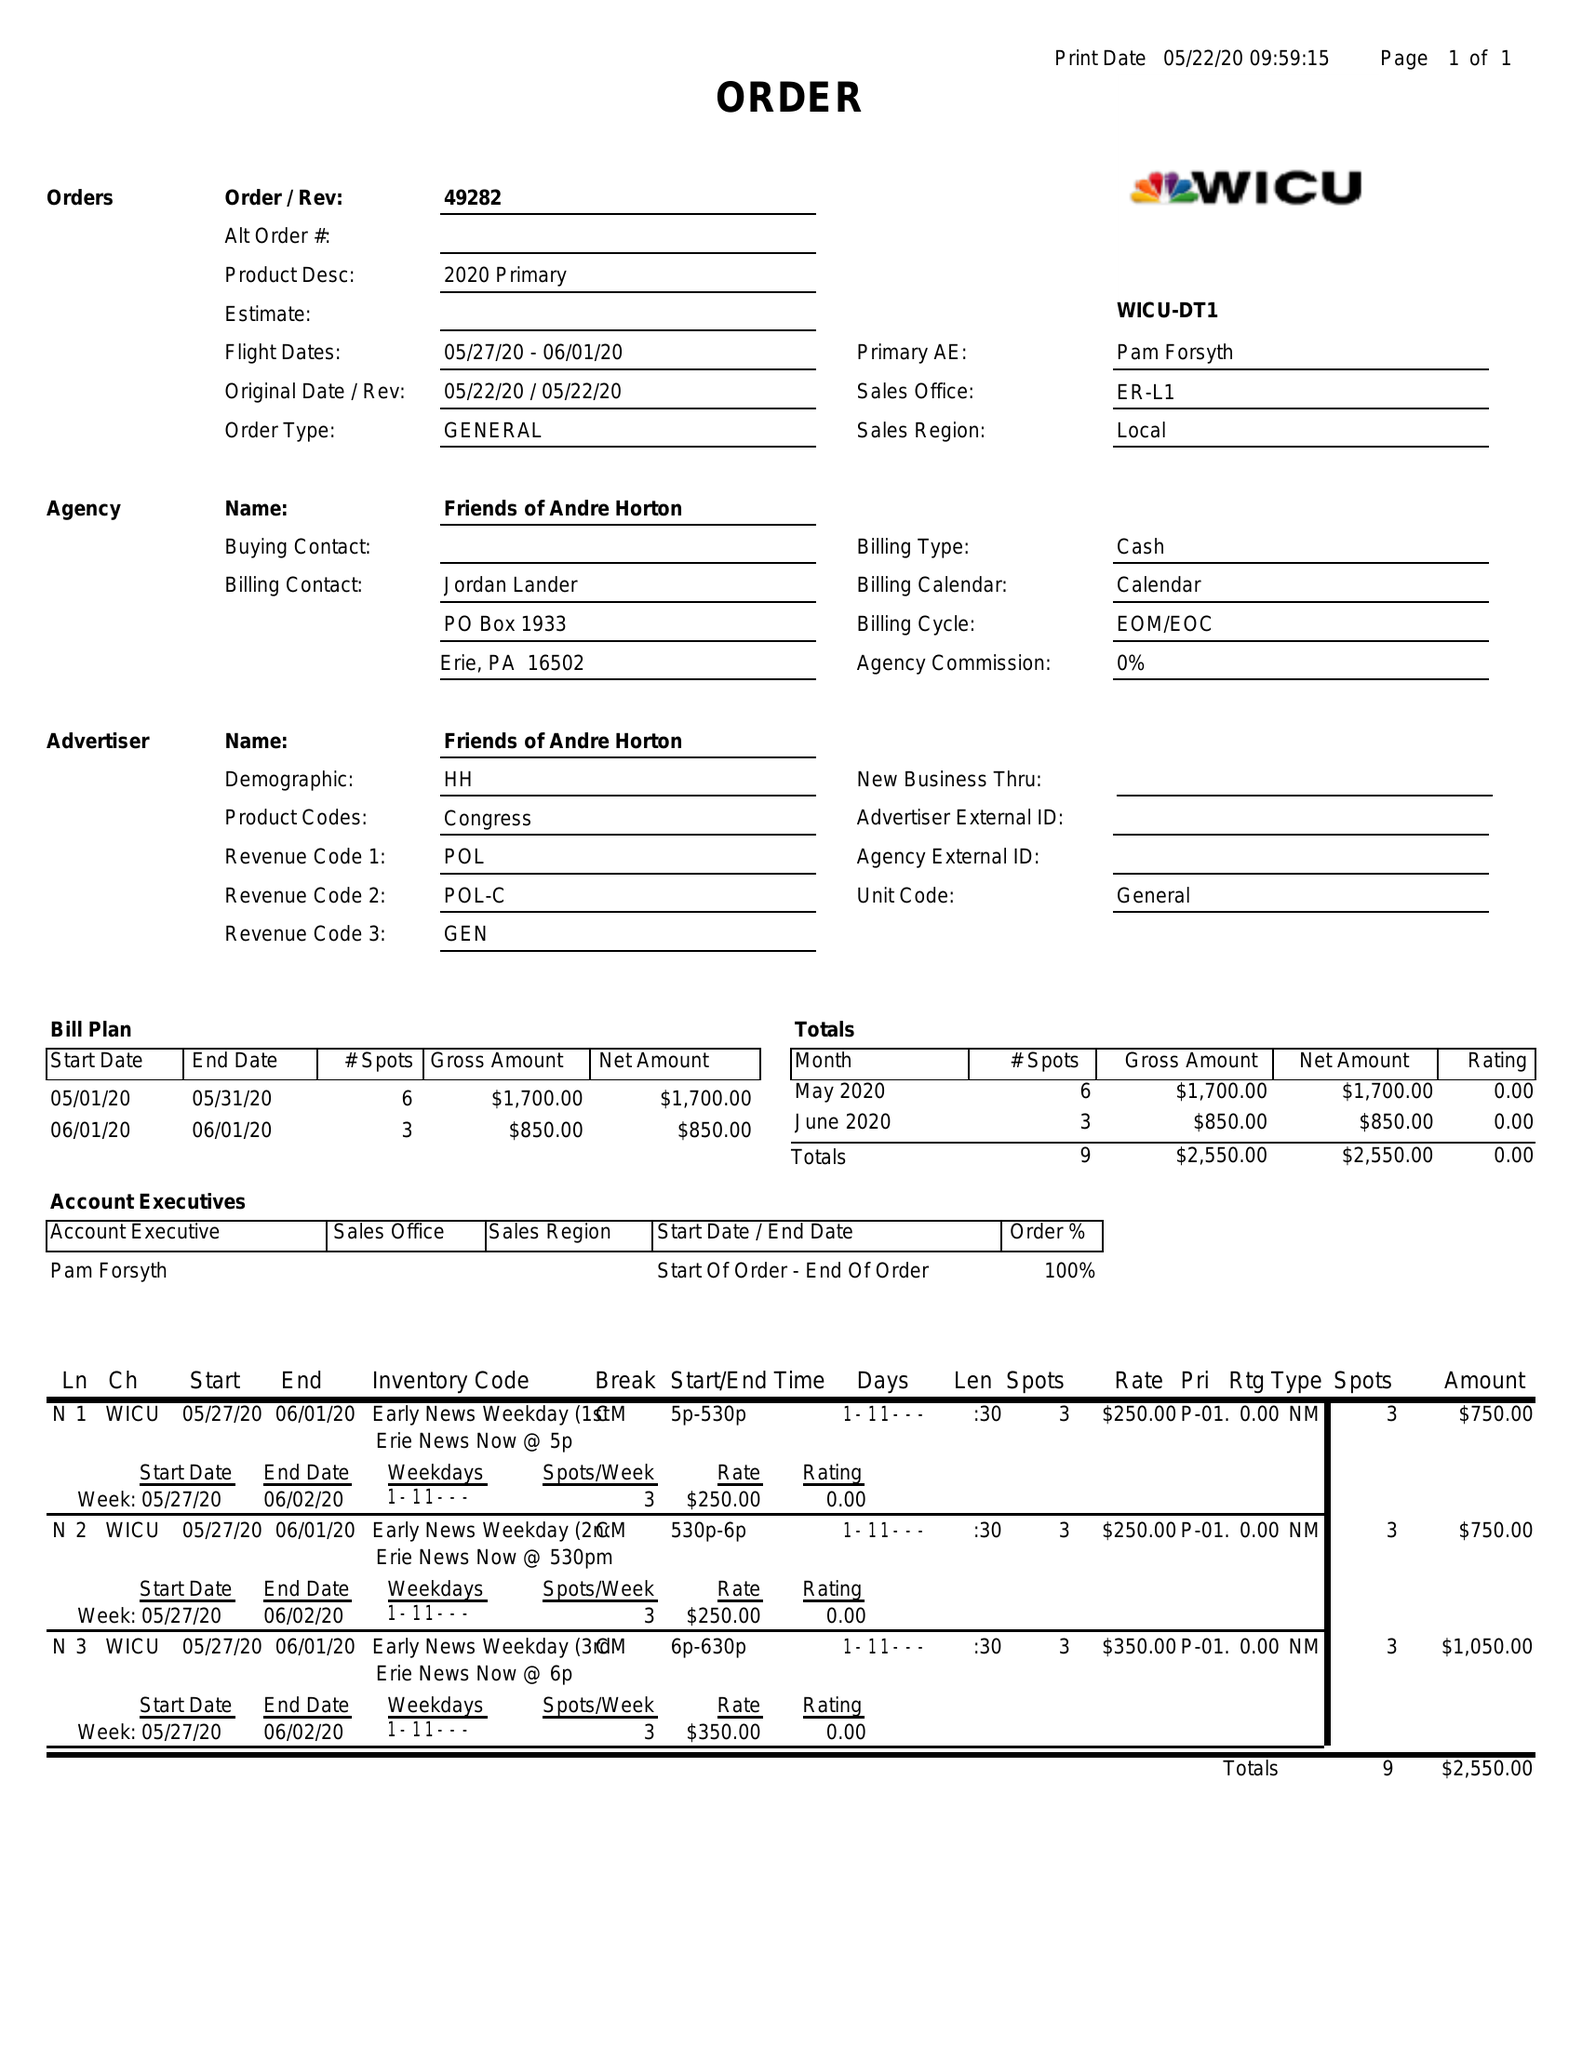What is the value for the flight_to?
Answer the question using a single word or phrase. 06/01/20 